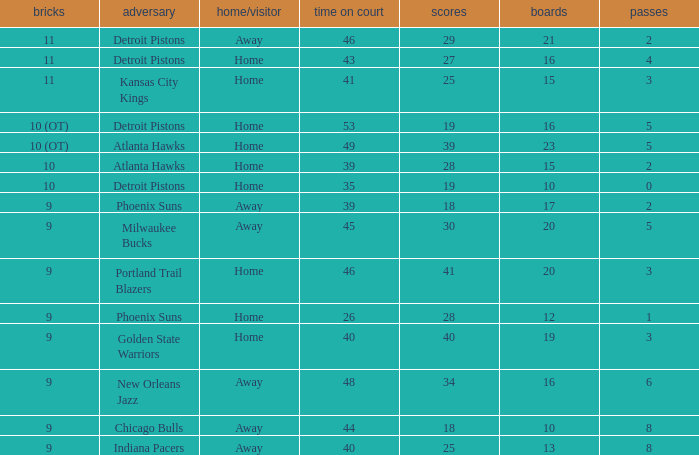How many minutes were played when there were 18 points and the opponent was Chicago Bulls? 1.0. Could you help me parse every detail presented in this table? {'header': ['bricks', 'adversary', 'home/visitor', 'time on court', 'scores', 'boards', 'passes'], 'rows': [['11', 'Detroit Pistons', 'Away', '46', '29', '21', '2'], ['11', 'Detroit Pistons', 'Home', '43', '27', '16', '4'], ['11', 'Kansas City Kings', 'Home', '41', '25', '15', '3'], ['10 (OT)', 'Detroit Pistons', 'Home', '53', '19', '16', '5'], ['10 (OT)', 'Atlanta Hawks', 'Home', '49', '39', '23', '5'], ['10', 'Atlanta Hawks', 'Home', '39', '28', '15', '2'], ['10', 'Detroit Pistons', 'Home', '35', '19', '10', '0'], ['9', 'Phoenix Suns', 'Away', '39', '18', '17', '2'], ['9', 'Milwaukee Bucks', 'Away', '45', '30', '20', '5'], ['9', 'Portland Trail Blazers', 'Home', '46', '41', '20', '3'], ['9', 'Phoenix Suns', 'Home', '26', '28', '12', '1'], ['9', 'Golden State Warriors', 'Home', '40', '40', '19', '3'], ['9', 'New Orleans Jazz', 'Away', '48', '34', '16', '6'], ['9', 'Chicago Bulls', 'Away', '44', '18', '10', '8'], ['9', 'Indiana Pacers', 'Away', '40', '25', '13', '8']]} 